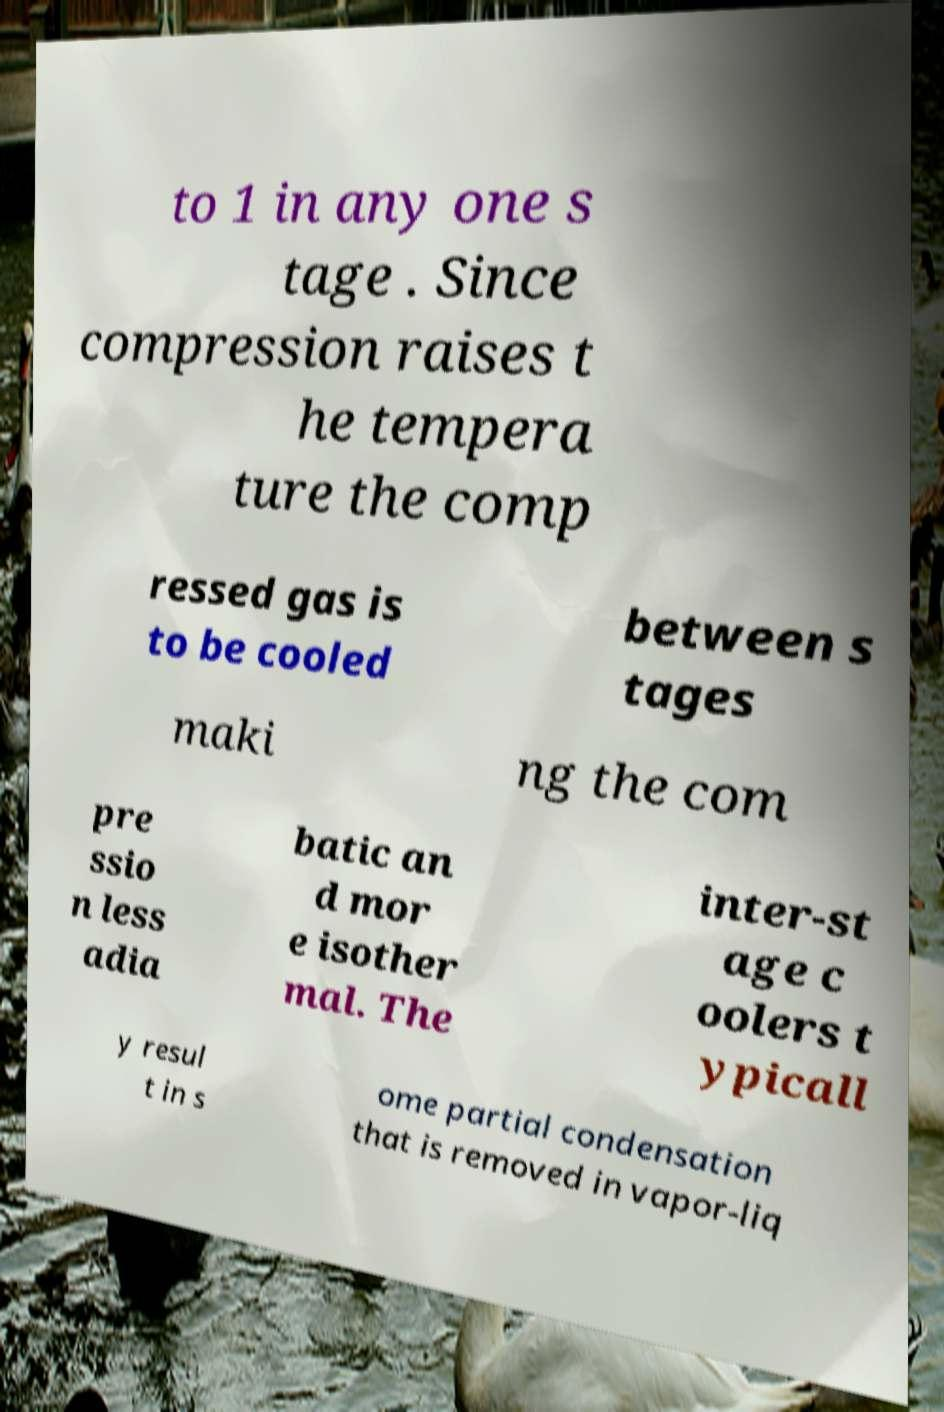Can you accurately transcribe the text from the provided image for me? to 1 in any one s tage . Since compression raises t he tempera ture the comp ressed gas is to be cooled between s tages maki ng the com pre ssio n less adia batic an d mor e isother mal. The inter-st age c oolers t ypicall y resul t in s ome partial condensation that is removed in vapor-liq 